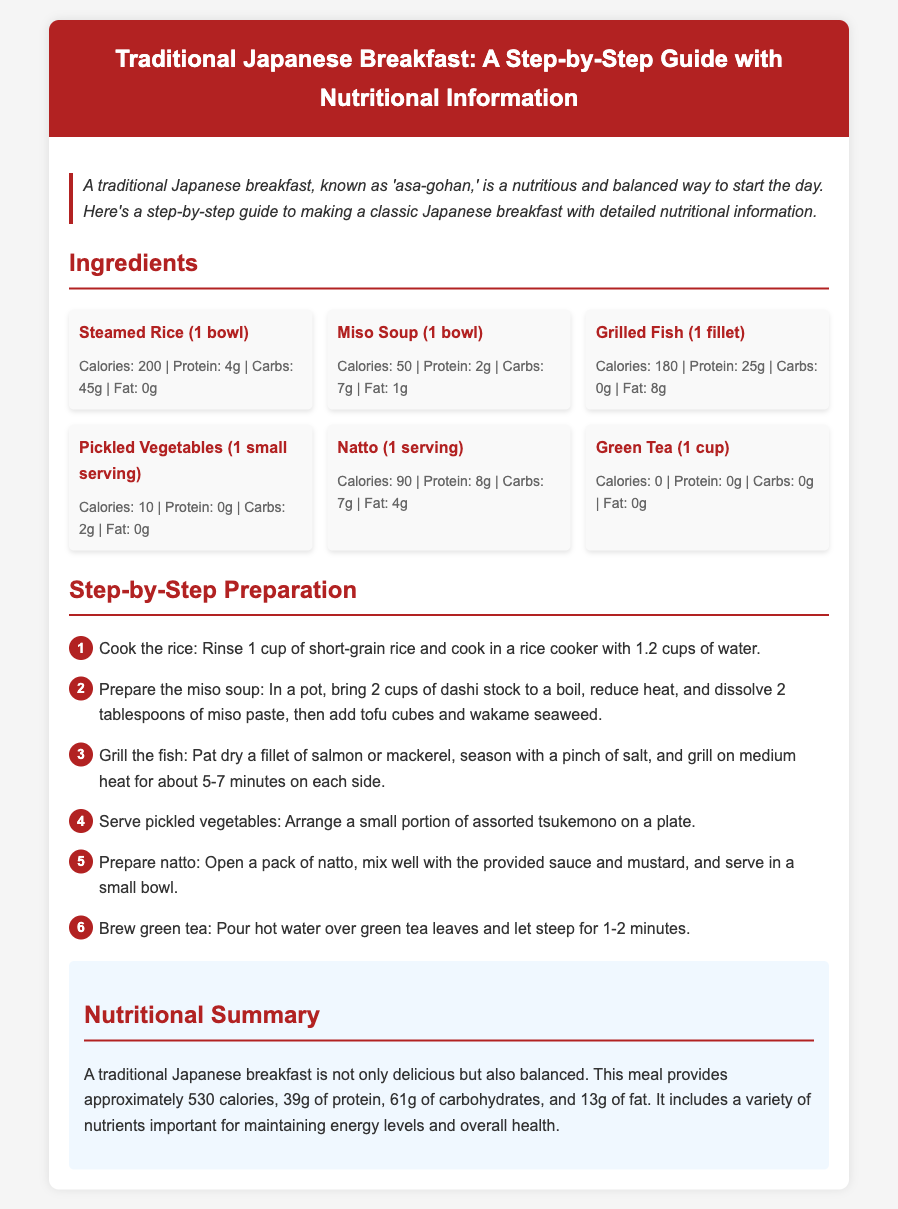What is the total calorie content of a traditional Japanese breakfast? The total calorie content is the sum of the calories from all the ingredients listed in the document: 200 + 50 + 180 + 10 + 90 + 0 = 530.
Answer: 530 What is the main beverage served with a traditional Japanese breakfast? The document lists green tea as the beverage to be brewed and served.
Answer: Green Tea How many grams of protein are in steamed rice? The document specifies that steamed rice contains 4 grams of protein.
Answer: 4g What is the nutritional value of pickled vegetables in terms of calories? The document states that pickled vegetables have a caloric value of 10 calories.
Answer: 10 What is the cooking time for grilling the fish? The document mentions that the fish should be grilled for about 5-7 minutes on each side.
Answer: 5-7 minutes What ingredient is used to prepare the miso soup? The document lists miso paste as a key ingredient to be dissolved in dashi stock.
Answer: Miso Paste How much fat is in natto? The nutritional information in the document states that natto contains 4 grams of fat.
Answer: 4g Which cooking appliance is used to prepare the rice? The document specifies the use of a rice cooker to cook the rice.
Answer: Rice Cooker What is the final step in preparing the traditional Japanese breakfast? The last step outlined in the document is to brew green tea.
Answer: Brew green tea 